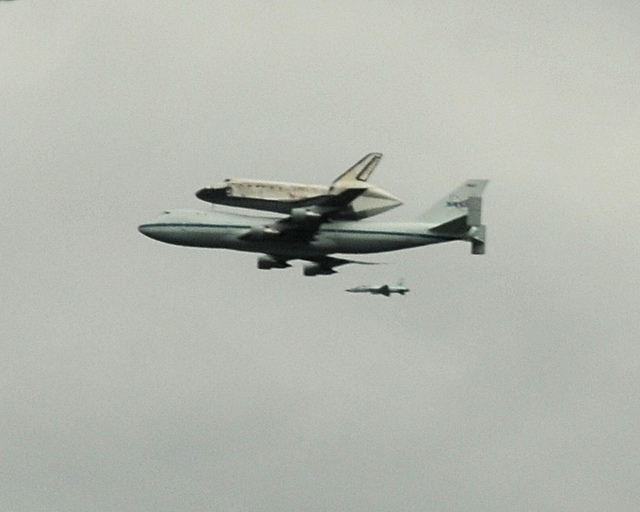<image>How many passenger airplanes are here? I don't know how many passenger airplanes are here. The answers are inconsistent. How many passenger airplanes are here? There is one passenger airplane in the image. 